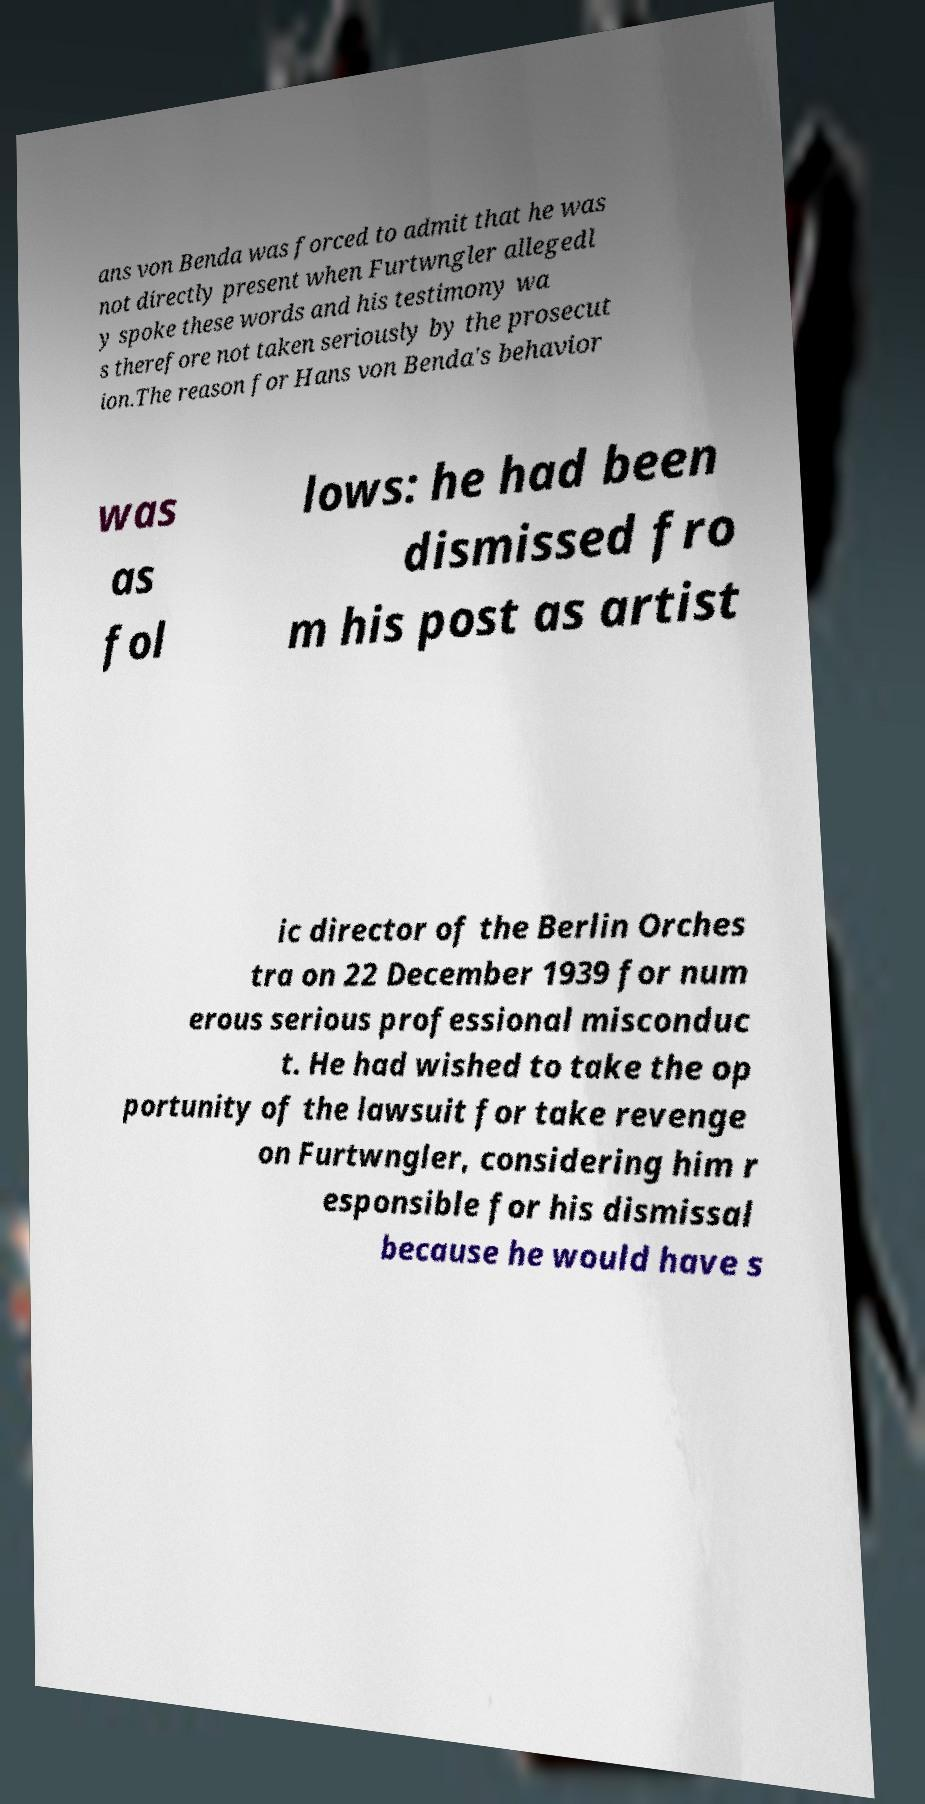There's text embedded in this image that I need extracted. Can you transcribe it verbatim? ans von Benda was forced to admit that he was not directly present when Furtwngler allegedl y spoke these words and his testimony wa s therefore not taken seriously by the prosecut ion.The reason for Hans von Benda's behavior was as fol lows: he had been dismissed fro m his post as artist ic director of the Berlin Orches tra on 22 December 1939 for num erous serious professional misconduc t. He had wished to take the op portunity of the lawsuit for take revenge on Furtwngler, considering him r esponsible for his dismissal because he would have s 